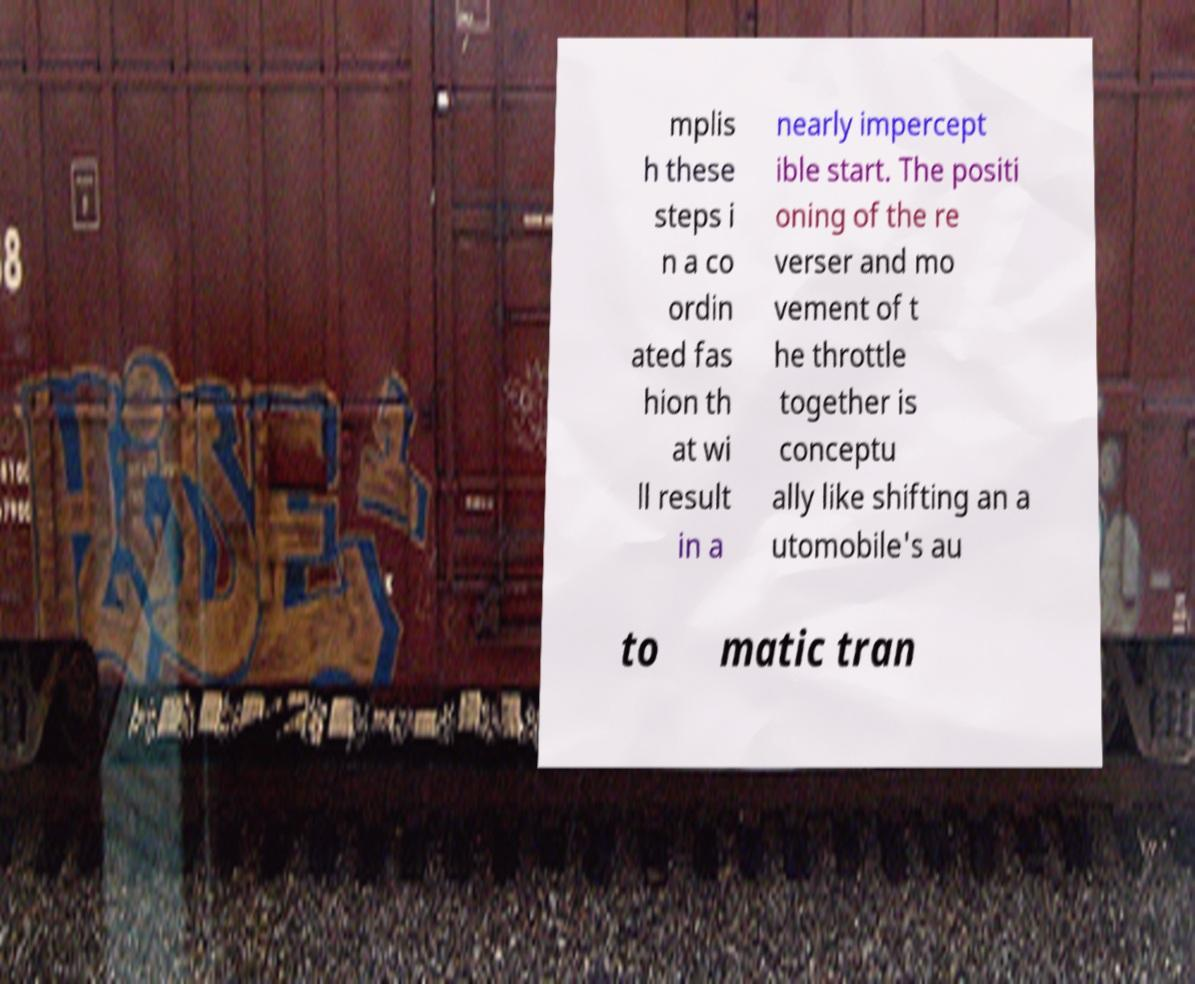Please read and relay the text visible in this image. What does it say? mplis h these steps i n a co ordin ated fas hion th at wi ll result in a nearly impercept ible start. The positi oning of the re verser and mo vement of t he throttle together is conceptu ally like shifting an a utomobile's au to matic tran 